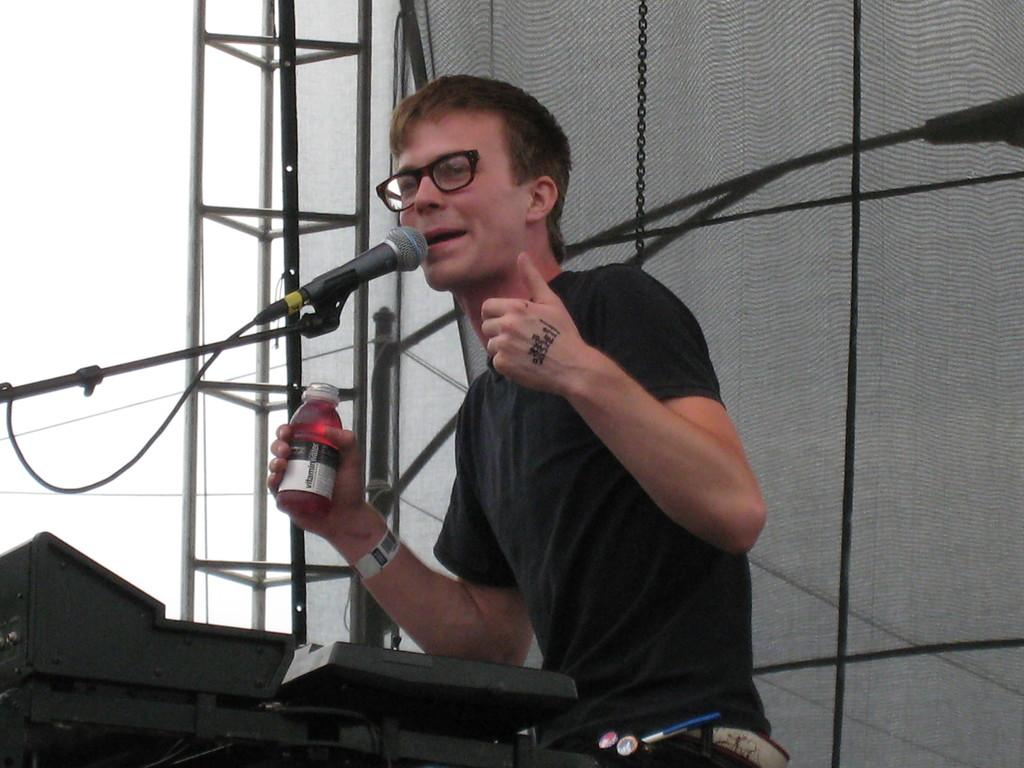What is the man in the image holding? The man is holding a bottle. What is the man doing with the mic in the image? The man is talking through a mic. Where is the mic positioned in relation to the man? The mic is in front of the man. What can be seen in the background of the image? There is a chain, a net, and a stand in the background of the image. What type of bath is the man taking in the image? There is no bath present in the image; the man is holding a bottle and talking through a mic. What kind of bun is the man eating in the image? There is no bun present in the image; the man is holding a bottle and talking through a mic. 